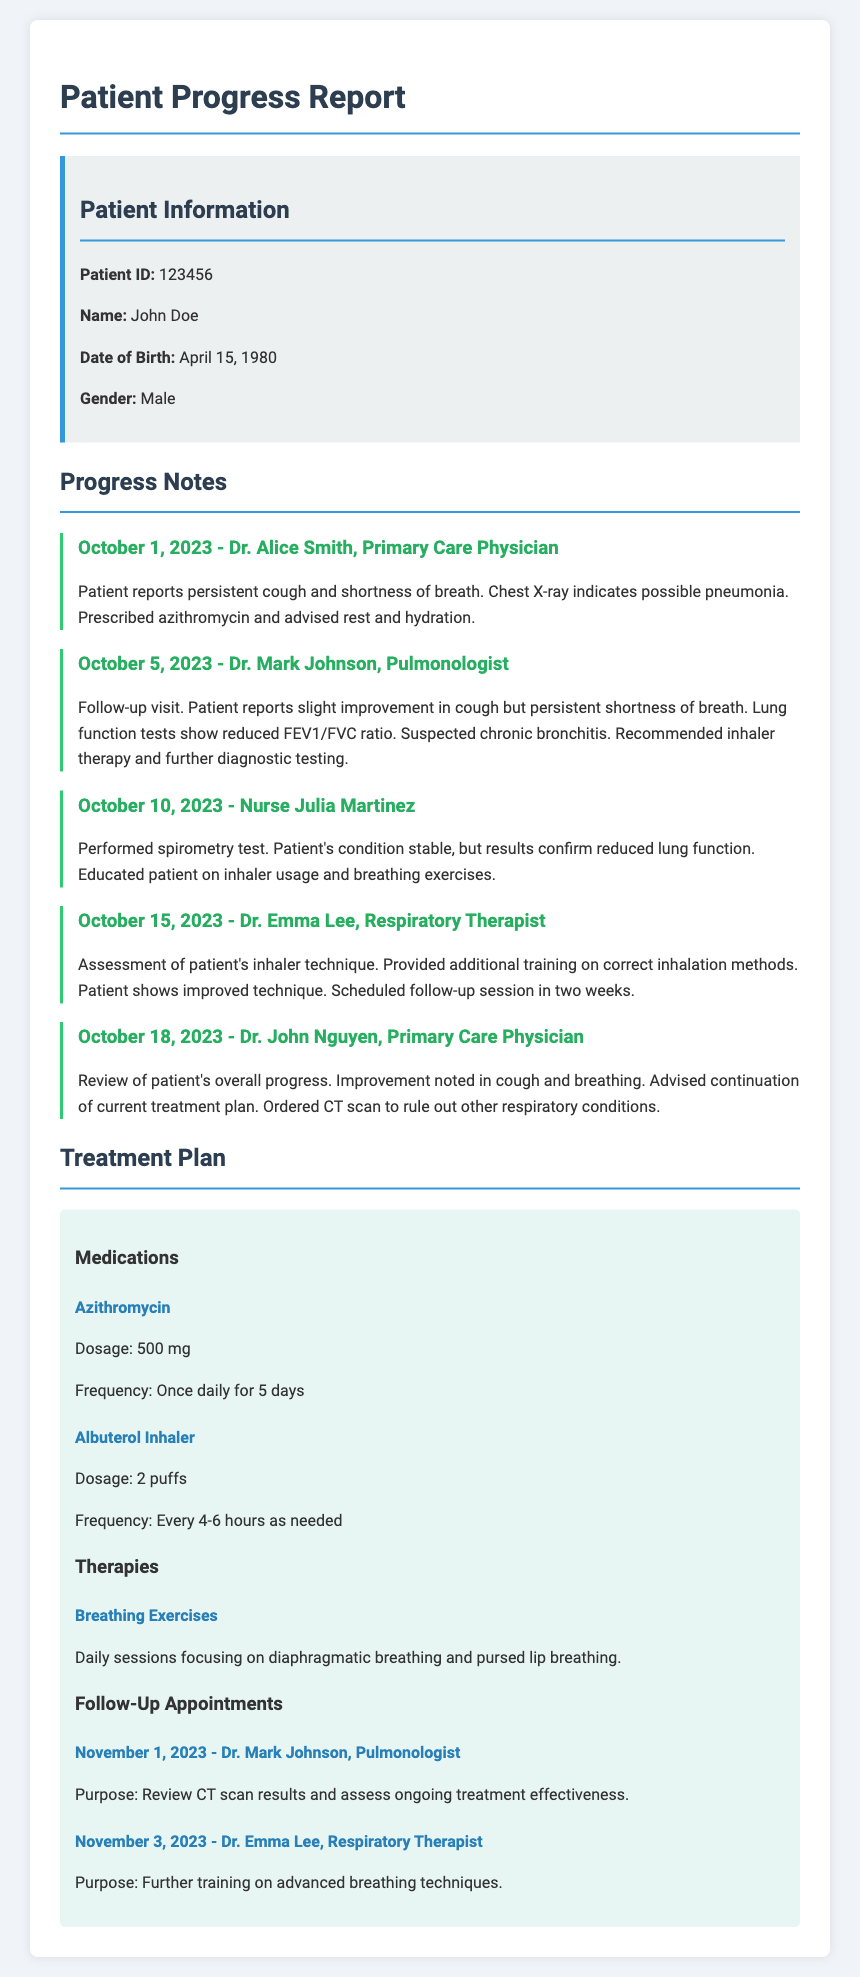What is the patient's name? The document provides patient information, including the name of the patient, which is John Doe.
Answer: John Doe What is the patient ID? The patient ID is mentioned in the patient information section of the document.
Answer: 123456 What medication was prescribed on October 1, 2023? The progress note from that date states that azithromycin was prescribed to the patient.
Answer: Azithromycin What is the follow-up appointment date with Dr. Mark Johnson? The treatment plan section lists the follow-up appointment with Dr. Mark Johnson on November 1, 2023.
Answer: November 1, 2023 What symptom did the patient report on October 5, 2023? The progress note on that date indicates that the patient reported a slight improvement in cough but persistent shortness of breath.
Answer: Persistent shortness of breath What treatment is advised for breathing issues? The treatment plan mentions several therapies, but daily breathing exercises are specifically suggested for the patient's condition.
Answer: Breathing Exercises How did the patient's inhaler technique change by October 15, 2023? The progress note around this date states that the patient shows improved technique after training on inhaler usage.
Answer: Improved technique What was the dosage for Azithromycin? The treatment plan specifies that the dosage for Azithromycin is 500 mg.
Answer: 500 mg What does the patient's CT scan aim to rule out? According to the progress note from October 18, the CT scan is ordered to rule out other respiratory conditions.
Answer: Other respiratory conditions 